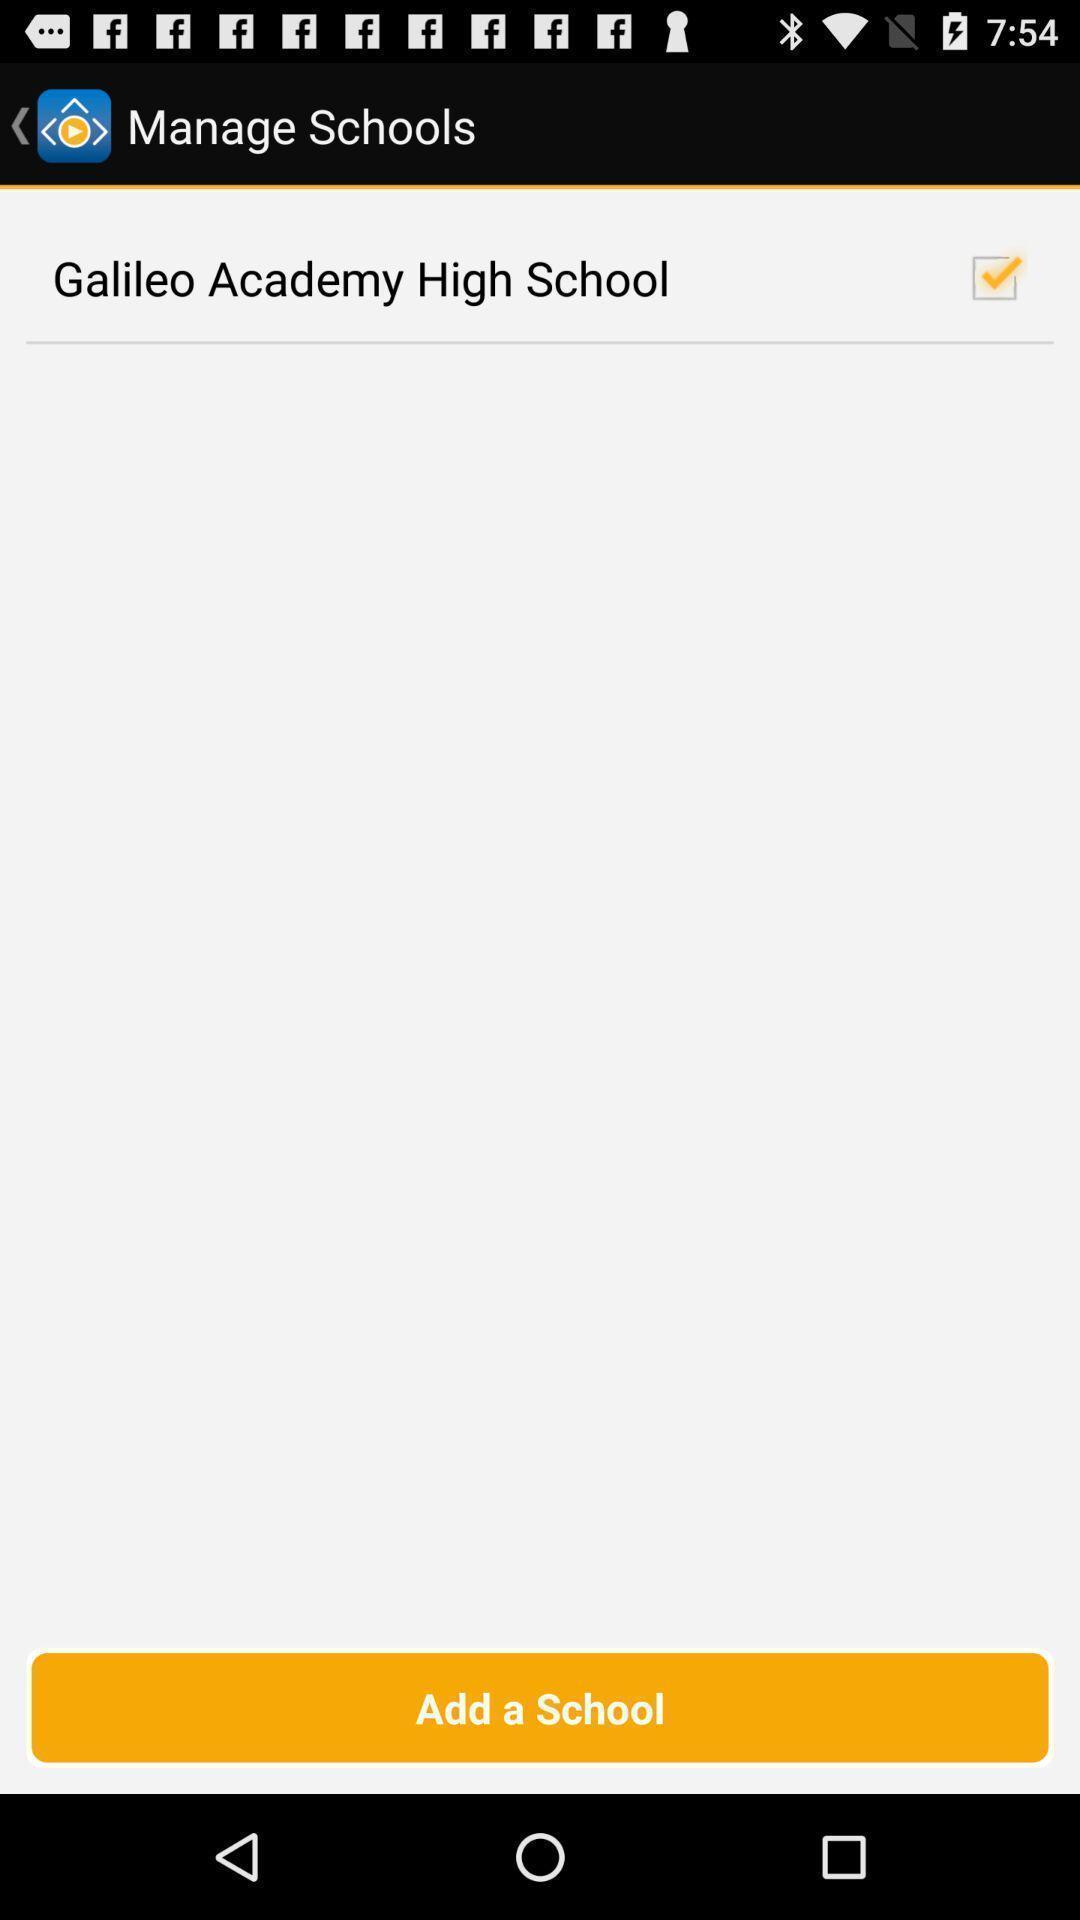Give me a summary of this screen capture. Screen showing add a school option. 